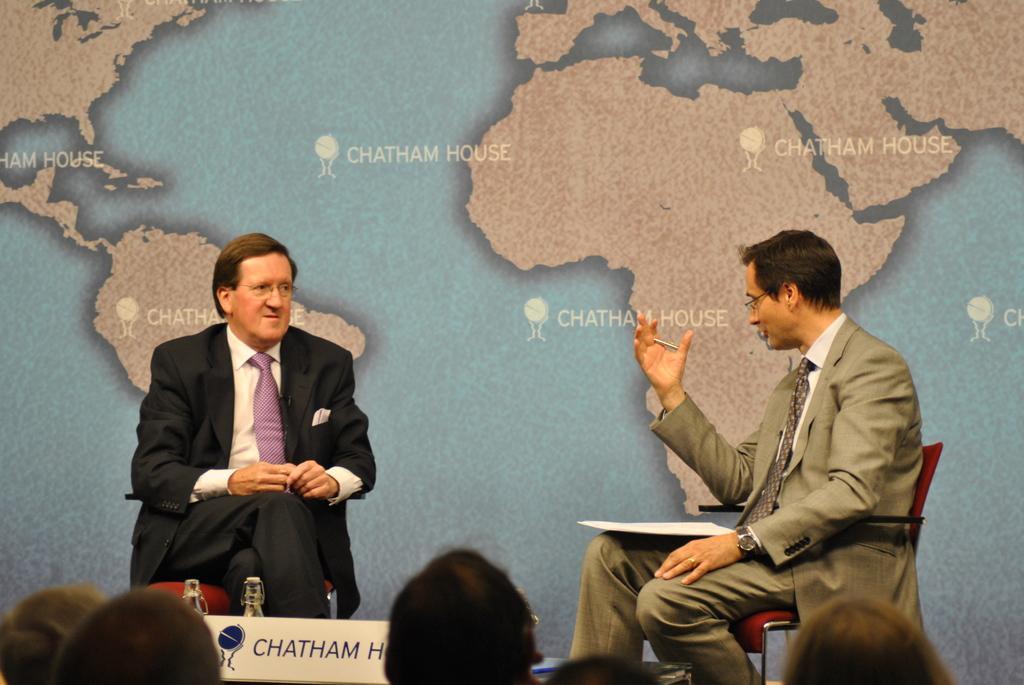In one or two sentences, can you explain what this image depicts? In this image I can see on the left man is sitting on the chair. He wore black color coat, trouser. At the bottom there is the name of him in a white color board. On the right side a man is sitting and speaking, he wore coat, tie, shirt. In the middle there is the world map image. At the bottom there are people. 